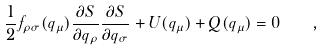Convert formula to latex. <formula><loc_0><loc_0><loc_500><loc_500>\frac { 1 } { 2 } f _ { \rho \sigma } ( q _ { \mu } ) \frac { \partial S } { \partial q _ { \rho } } \frac { \partial S } { \partial q _ { \sigma } } + U ( q _ { \mu } ) + Q ( q _ { \mu } ) = 0 \quad ,</formula> 